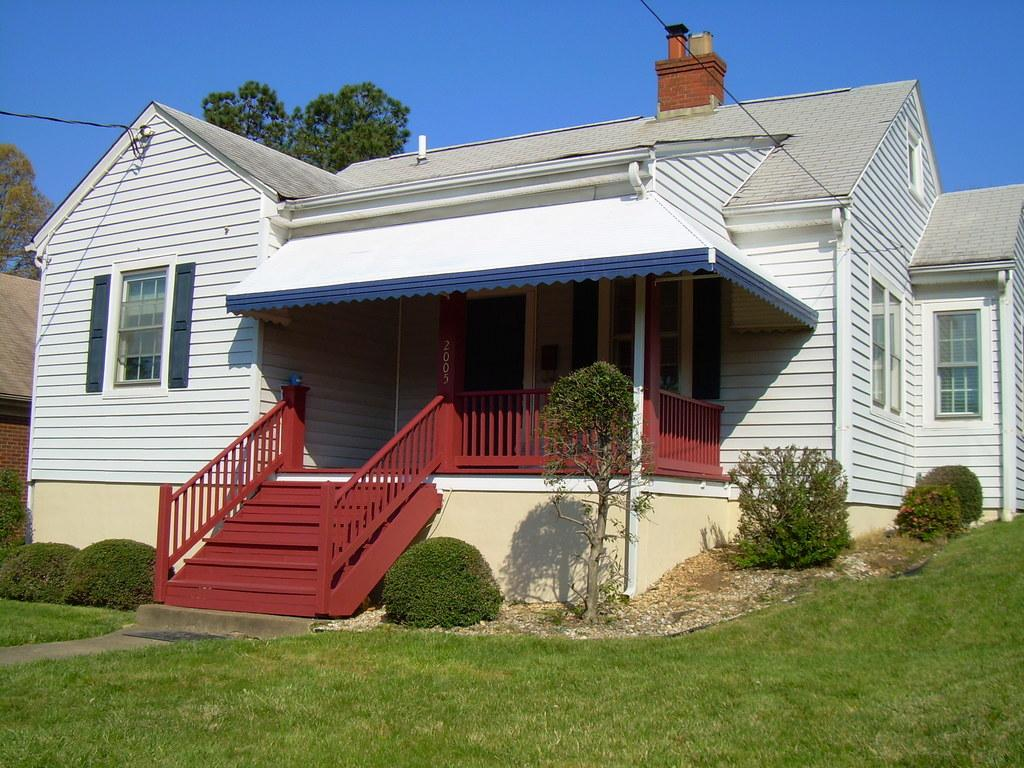What type of structures are present in the image? There are houses in the image. What can be seen in front of the houses? There are plants and grass in front of the houses. What is visible behind the houses? There are cables and trees behind the houses. What part of the natural environment is visible in the image? The sky is visible in the image. How many bikes are parked in the yard in the image? There is no yard or bikes present in the image. What color is the lipstick on the person in the image? There are no people or lipstick present in the image. 